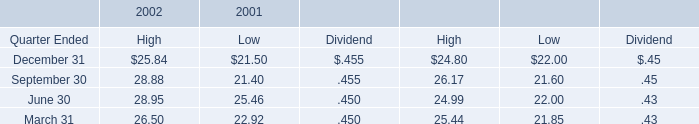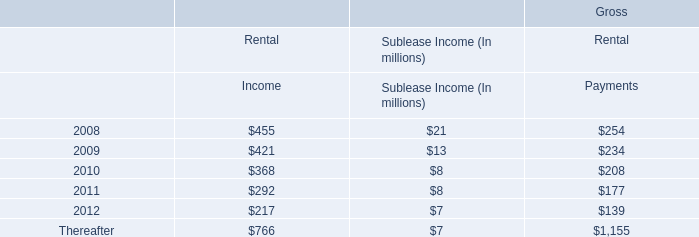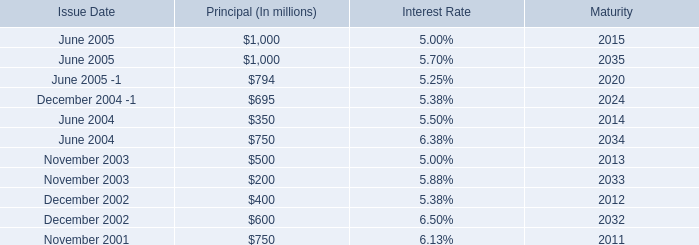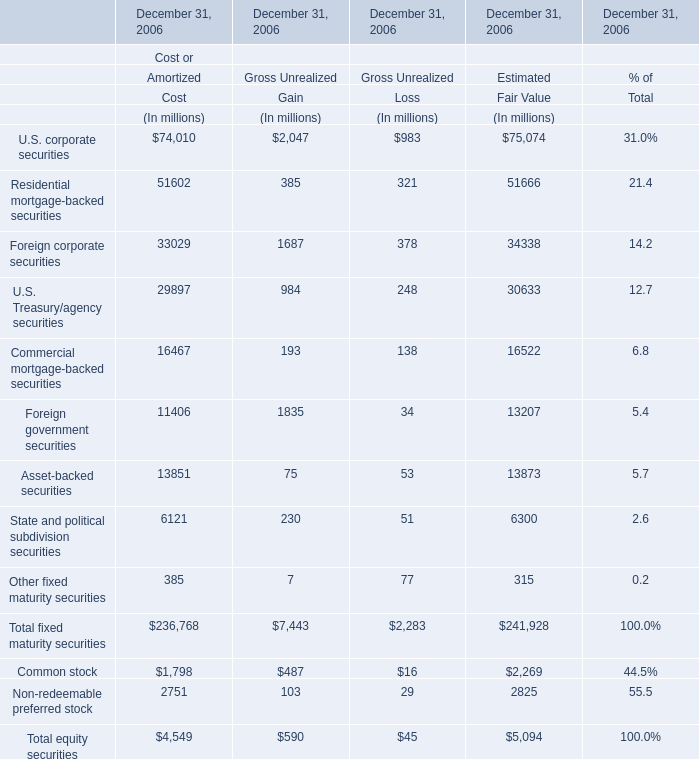What do all Gain sum up in 2006 , excluding Common stock and Non-redeemable preferred stock? (in million) 
Answer: 7443. 